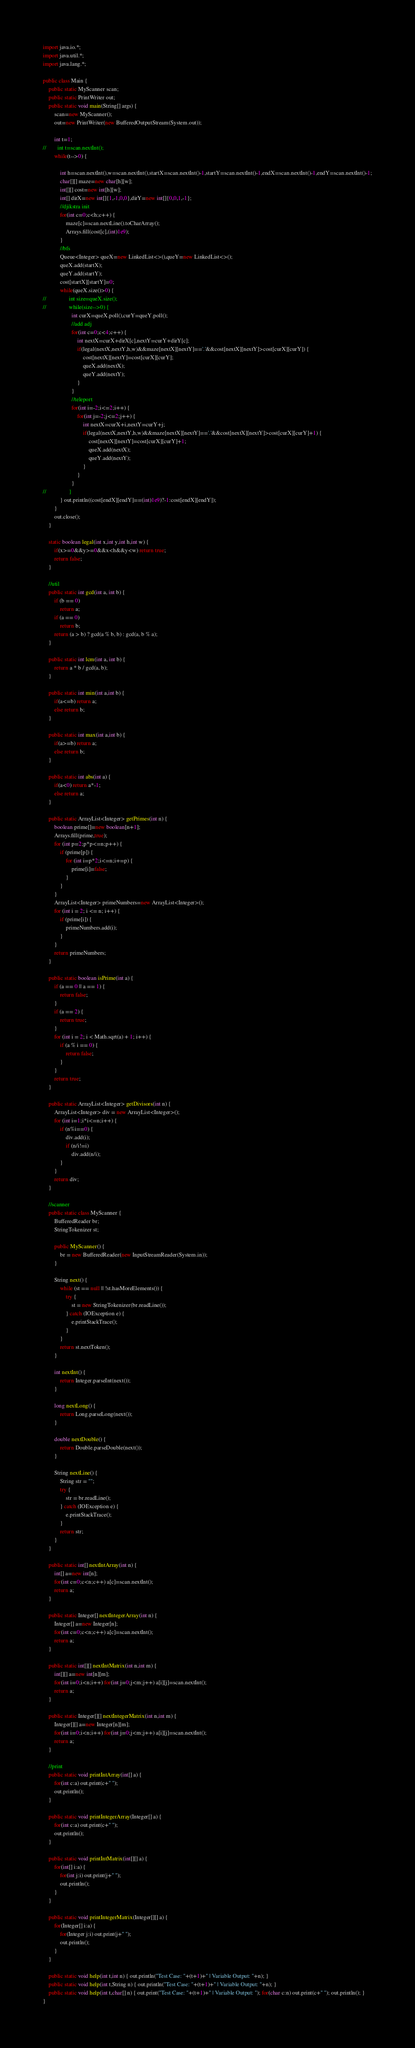Convert code to text. <code><loc_0><loc_0><loc_500><loc_500><_Java_>import java.io.*;
import java.util.*;
import java.lang.*;

public class Main {
    public static MyScanner scan;
    public static PrintWriter out;
    public static void main(String[] args) {
        scan=new MyScanner();
        out=new PrintWriter(new BufferedOutputStream(System.out));

        int t=1;
//        int t=scan.nextInt();
        while(t-->0) {

            int h=scan.nextInt(),w=scan.nextInt(),startX=scan.nextInt()-1,startY=scan.nextInt()-1,endX=scan.nextInt()-1,endY=scan.nextInt()-1;
            char[][] maze=new char[h][w];
            int[][] cost=new int[h][w];
            int[] dirX=new int[]{1,-1,0,0},dirY=new int[]{0,0,1,-1};
            //djikstra init
            for(int c=0;c<h;c++) {
                maze[c]=scan.nextLine().toCharArray();
                Arrays.fill(cost[c],(int)1e9);
            }
            //bfs
            Queue<Integer> queX=new LinkedList<>(),queY=new LinkedList<>();
            queX.add(startX);
            queY.add(startY);
            cost[startX][startY]=0;
            while(queX.size()>0) {
//                int size=queX.size();
//                while(size-->0) {
                    int curX=queX.poll(),curY=queY.poll();
                    //add adj
                    for(int c=0;c<4;c++) {
                        int nextX=curX+dirX[c],nextY=curY+dirY[c];
                        if(legal(nextX,nextY,h,w)&&maze[nextX][nextY]=='.'&&cost[nextX][nextY]>cost[curX][curY]) {
                            cost[nextX][nextY]=cost[curX][curY];
                            queX.add(nextX);
                            queY.add(nextY);
                        }
                    }
                    //teleport
                    for(int i=-2;i<=2;i++) {
                        for(int j=-2;j<=2;j++) {
                            int nextX=curX+i,nextY=curY+j;
                            if(legal(nextX,nextY,h,w)&&maze[nextX][nextY]=='.'&&cost[nextX][nextY]>cost[curX][curY]+1) {
                                cost[nextX][nextY]=cost[curX][curY]+1;
                                queX.add(nextX);
                                queY.add(nextY);
                            }
                        }
                    }
//                }
            } out.println((cost[endX][endY]==(int)1e9)?-1:cost[endX][endY]);
        }
        out.close();
    }

    static boolean legal(int x,int y,int h,int w) {
        if(x>=0&&y>=0&&x<h&&y<w) return true;
        return false;
    }

    //util
    public static int gcd(int a, int b) {
        if (b == 0)
            return a;
        if (a == 0)
            return b;
        return (a > b) ? gcd(a % b, b) : gcd(a, b % a);
    }

    public static int lcm(int a, int b) {
        return a * b / gcd(a, b);
    }

    public static int min(int a,int b) {
        if(a<=b) return a;
        else return b;
    }

    public static int max(int a,int b) {
        if(a>=b) return a;
        else return b;
    }

    public static int abs(int a) {
        if(a<0) return a*-1;
        else return a;
    }

    public static ArrayList<Integer> getPrimes(int n) {
        boolean prime[]=new boolean[n+1];
        Arrays.fill(prime,true);
        for (int p=2;p*p<=n;p++) {
            if (prime[p]) {
                for (int i=p*2;i<=n;i+=p) {
                    prime[i]=false;
                }
            }
        }
        ArrayList<Integer> primeNumbers=new ArrayList<Integer>();
        for (int i = 2; i <= n; i++) {
            if (prime[i]) {
                primeNumbers.add(i);
            }
        }
        return primeNumbers;
    }

    public static boolean isPrime(int a) {
        if (a == 0 || a == 1) {
            return false;
        }
        if (a == 2) {
            return true;
        }
        for (int i = 2; i < Math.sqrt(a) + 1; i++) {
            if (a % i == 0) {
                return false;
            }
        }
        return true;
    }

    public static ArrayList<Integer> getDivisors(int n) {
        ArrayList<Integer> div = new ArrayList<Integer>();
        for (int i=1;i*i<=n;i++) {
            if (n%i==0) {
                div.add(i);
                if (n/i!=i)
                    div.add(n/i);
            }
        }
        return div;
    }

    //scanner
    public static class MyScanner {
        BufferedReader br;
        StringTokenizer st;

        public MyScanner() {
            br = new BufferedReader(new InputStreamReader(System.in));
        }

        String next() {
            while (st == null || !st.hasMoreElements()) {
                try {
                    st = new StringTokenizer(br.readLine());
                } catch (IOException e) {
                    e.printStackTrace();
                }
            }
            return st.nextToken();
        }

        int nextInt() {
            return Integer.parseInt(next());
        }

        long nextLong() {
            return Long.parseLong(next());
        }

        double nextDouble() {
            return Double.parseDouble(next());
        }

        String nextLine() {
            String str = "";
            try {
                str = br.readLine();
            } catch (IOException e) {
                e.printStackTrace();
            }
            return str;
        }
    }

    public static int[] nextIntArray(int n) {
        int[] a=new int[n];
        for(int c=0;c<n;c++) a[c]=scan.nextInt();
        return a;
    }

    public static Integer[] nextIntegerArray(int n) {
        Integer[] a=new Integer[n];
        for(int c=0;c<n;c++) a[c]=scan.nextInt();
        return a;
    }

    public static int[][] nextIntMatrix(int n,int m) {
        int[][] a=new int[n][m];
        for(int i=0;i<n;i++) for(int j=0;j<m;j++) a[i][j]=scan.nextInt();
        return a;
    }

    public static Integer[][] nextIntegerMatrix(int n,int m) {
        Integer[][] a=new Integer[n][m];
        for(int i=0;i<n;i++) for(int j=0;j<m;j++) a[i][j]=scan.nextInt();
        return a;
    }

    //print
    public static void printIntArray(int[] a) {
        for(int c:a) out.print(c+" ");
        out.println();
    }

    public static void printIntegerArray(Integer[] a) {
        for(int c:a) out.print(c+" ");
        out.println();
    }

    public static void printIntMatrix(int[][] a) {
        for(int[] i:a) {
            for(int j:i) out.print(j+" ");
            out.println();
        }
    }

    public static void printIntegerMatrix(Integer[][] a) {
        for(Integer[] i:a) {
            for(Integer j:i) out.print(j+" ");
            out.println();
        }
    }

    public static void help(int t,int n) { out.println("Test Case: "+(t+1)+" | Variable Output: "+n); }
    public static void help(int t,String n) { out.println("Test Case: "+(t+1)+" | Variable Output: "+n); }
    public static void help(int t,char[] n) { out.print("Test Case: "+(t+1)+" | Variable Output: "); for(char c:n) out.print(c+" "); out.println(); }
}</code> 